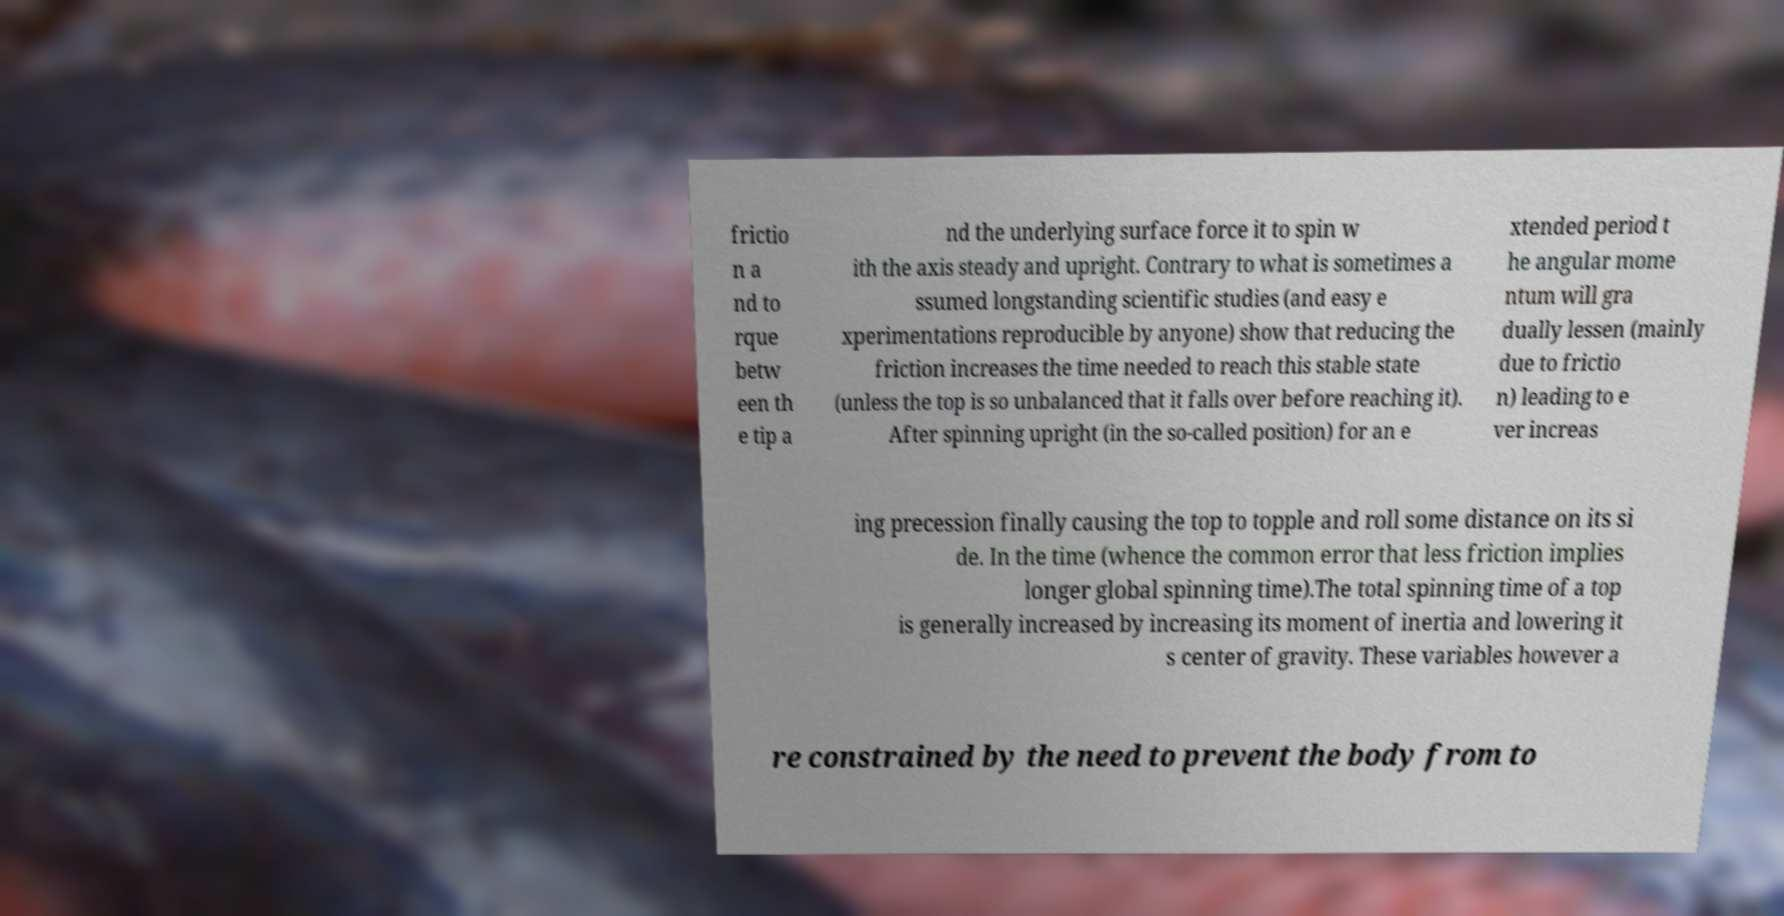There's text embedded in this image that I need extracted. Can you transcribe it verbatim? frictio n a nd to rque betw een th e tip a nd the underlying surface force it to spin w ith the axis steady and upright. Contrary to what is sometimes a ssumed longstanding scientific studies (and easy e xperimentations reproducible by anyone) show that reducing the friction increases the time needed to reach this stable state (unless the top is so unbalanced that it falls over before reaching it). After spinning upright (in the so-called position) for an e xtended period t he angular mome ntum will gra dually lessen (mainly due to frictio n) leading to e ver increas ing precession finally causing the top to topple and roll some distance on its si de. In the time (whence the common error that less friction implies longer global spinning time).The total spinning time of a top is generally increased by increasing its moment of inertia and lowering it s center of gravity. These variables however a re constrained by the need to prevent the body from to 